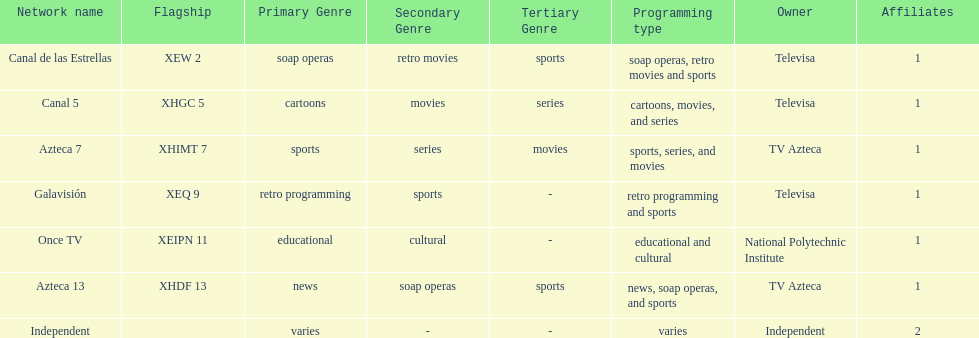How many affiliates does galavision have? 1. 